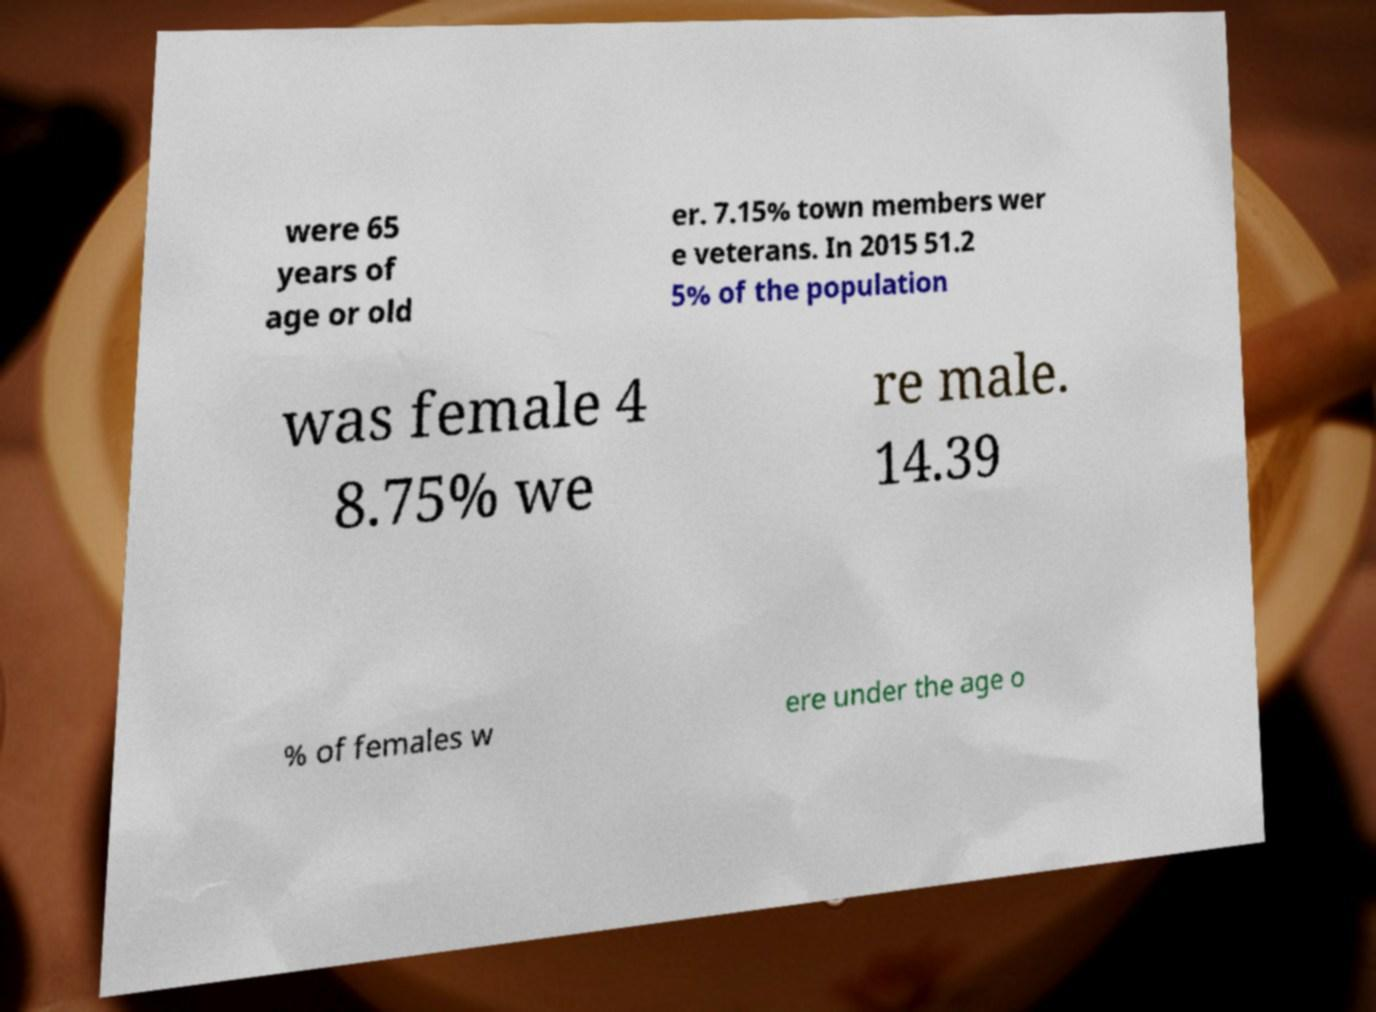For documentation purposes, I need the text within this image transcribed. Could you provide that? were 65 years of age or old er. 7.15% town members wer e veterans. In 2015 51.2 5% of the population was female 4 8.75% we re male. 14.39 % of females w ere under the age o 